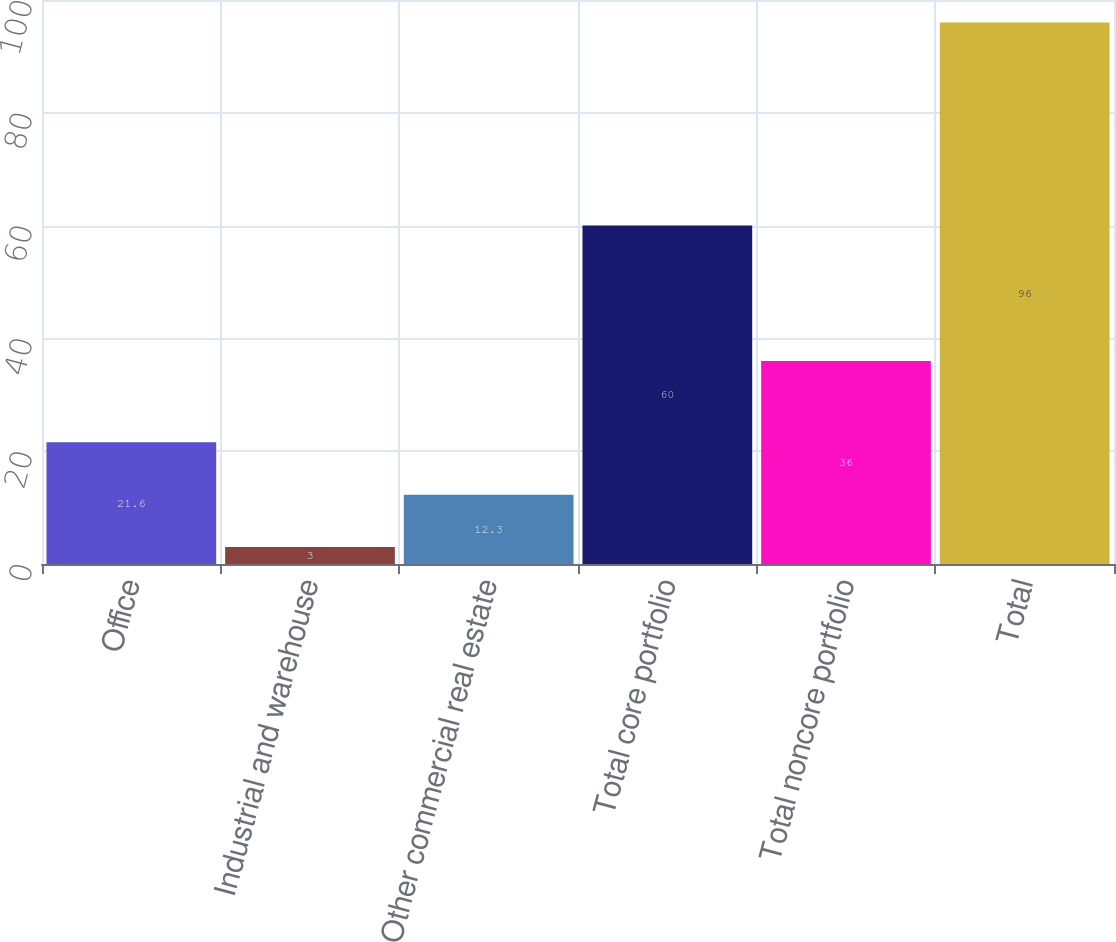Convert chart to OTSL. <chart><loc_0><loc_0><loc_500><loc_500><bar_chart><fcel>Office<fcel>Industrial and warehouse<fcel>Other commercial real estate<fcel>Total core portfolio<fcel>Total noncore portfolio<fcel>Total<nl><fcel>21.6<fcel>3<fcel>12.3<fcel>60<fcel>36<fcel>96<nl></chart> 